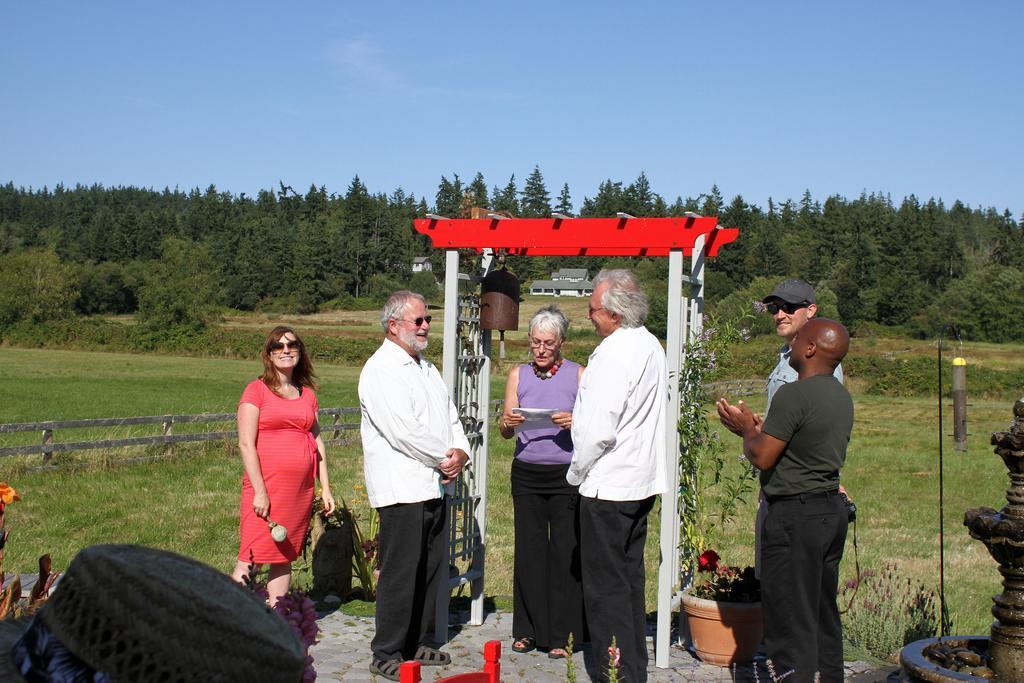In one or two sentences, can you explain what this image depicts? This is an outside view. Here I can see few people are standing. At the back of these people I can see few metal poles. I can see the grass on the ground. On the left side there is a fencing. In the background, I can see many trees and few houses. At the top of the image I can see the sky. 